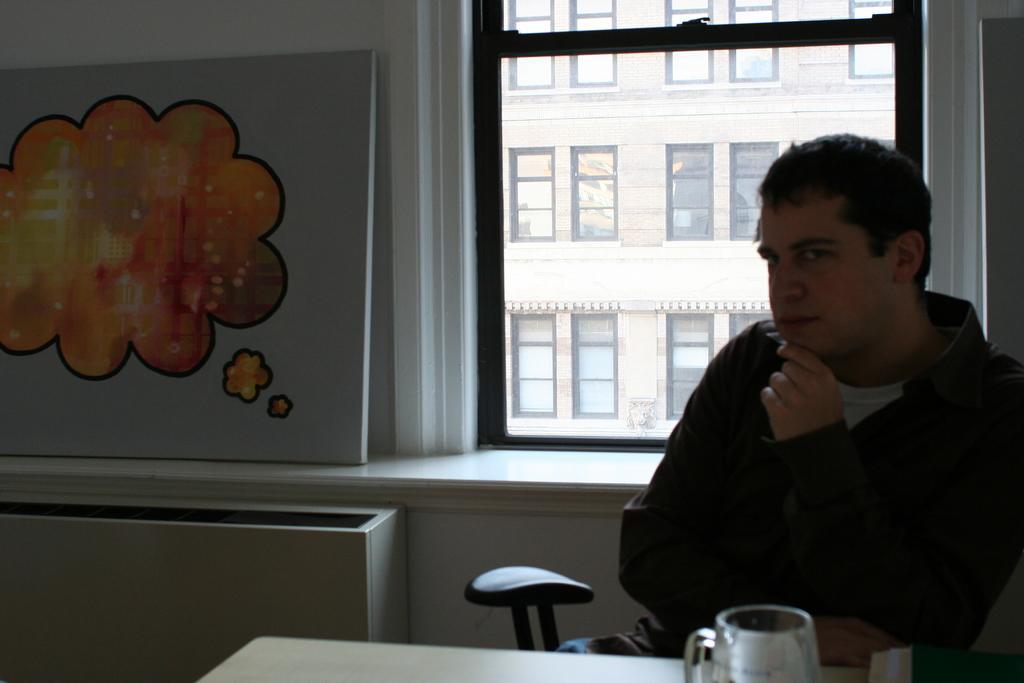Could you give a brief overview of what you see in this image? As we can see in the image there is a white color wall, banner, windows, a man wearing black color jacket and sitting on chair. In front of him there is a table. On table there is mug. 